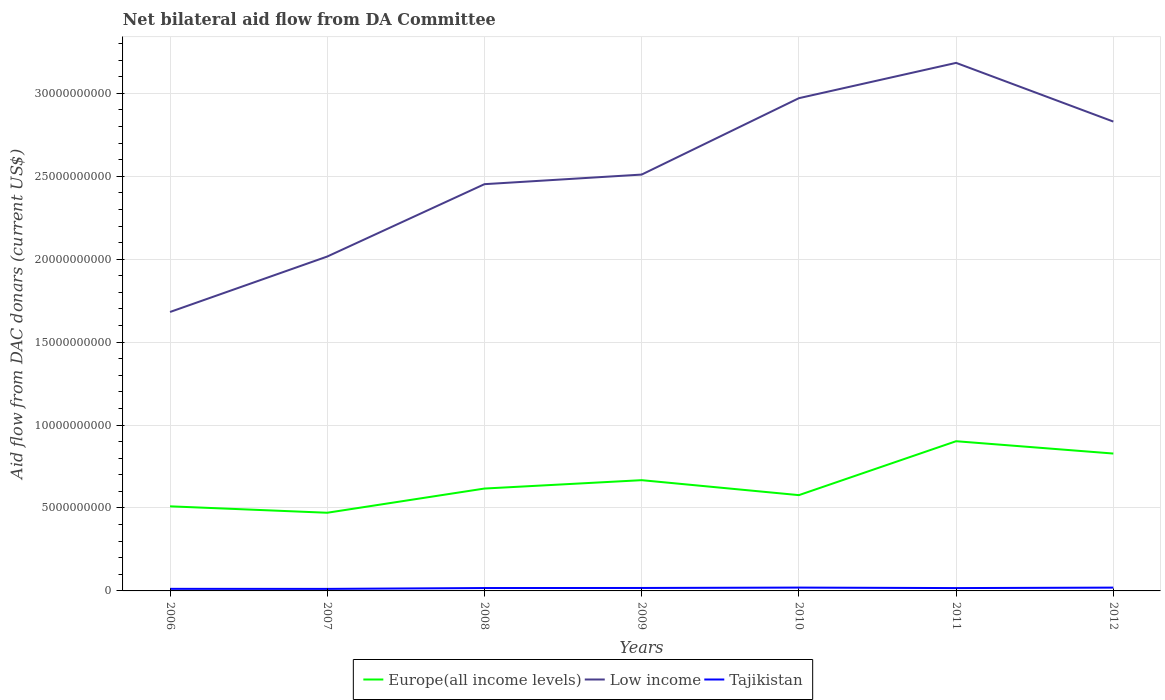Does the line corresponding to Tajikistan intersect with the line corresponding to Europe(all income levels)?
Your response must be concise. No. Is the number of lines equal to the number of legend labels?
Your response must be concise. Yes. Across all years, what is the maximum aid flow in in Europe(all income levels)?
Provide a short and direct response. 4.71e+09. What is the total aid flow in in Europe(all income levels) in the graph?
Ensure brevity in your answer.  3.97e+08. What is the difference between the highest and the second highest aid flow in in Europe(all income levels)?
Your answer should be very brief. 4.31e+09. What is the difference between the highest and the lowest aid flow in in Europe(all income levels)?
Provide a short and direct response. 3. How many years are there in the graph?
Your response must be concise. 7. Does the graph contain any zero values?
Provide a succinct answer. No. Does the graph contain grids?
Offer a terse response. Yes. How many legend labels are there?
Ensure brevity in your answer.  3. How are the legend labels stacked?
Offer a terse response. Horizontal. What is the title of the graph?
Give a very brief answer. Net bilateral aid flow from DA Committee. Does "Jamaica" appear as one of the legend labels in the graph?
Offer a terse response. No. What is the label or title of the Y-axis?
Your answer should be very brief. Aid flow from DAC donars (current US$). What is the Aid flow from DAC donars (current US$) in Europe(all income levels) in 2006?
Your answer should be compact. 5.10e+09. What is the Aid flow from DAC donars (current US$) of Low income in 2006?
Your answer should be compact. 1.68e+1. What is the Aid flow from DAC donars (current US$) of Tajikistan in 2006?
Offer a terse response. 1.25e+08. What is the Aid flow from DAC donars (current US$) in Europe(all income levels) in 2007?
Your response must be concise. 4.71e+09. What is the Aid flow from DAC donars (current US$) in Low income in 2007?
Provide a short and direct response. 2.02e+1. What is the Aid flow from DAC donars (current US$) of Tajikistan in 2007?
Provide a succinct answer. 1.22e+08. What is the Aid flow from DAC donars (current US$) of Europe(all income levels) in 2008?
Provide a succinct answer. 6.17e+09. What is the Aid flow from DAC donars (current US$) in Low income in 2008?
Your answer should be very brief. 2.45e+1. What is the Aid flow from DAC donars (current US$) in Tajikistan in 2008?
Offer a terse response. 1.75e+08. What is the Aid flow from DAC donars (current US$) of Europe(all income levels) in 2009?
Your answer should be very brief. 6.68e+09. What is the Aid flow from DAC donars (current US$) of Low income in 2009?
Ensure brevity in your answer.  2.51e+1. What is the Aid flow from DAC donars (current US$) in Tajikistan in 2009?
Your answer should be compact. 1.78e+08. What is the Aid flow from DAC donars (current US$) in Europe(all income levels) in 2010?
Make the answer very short. 5.78e+09. What is the Aid flow from DAC donars (current US$) of Low income in 2010?
Make the answer very short. 2.97e+1. What is the Aid flow from DAC donars (current US$) in Tajikistan in 2010?
Ensure brevity in your answer.  2.01e+08. What is the Aid flow from DAC donars (current US$) of Europe(all income levels) in 2011?
Your response must be concise. 9.03e+09. What is the Aid flow from DAC donars (current US$) in Low income in 2011?
Ensure brevity in your answer.  3.18e+1. What is the Aid flow from DAC donars (current US$) in Tajikistan in 2011?
Provide a short and direct response. 1.72e+08. What is the Aid flow from DAC donars (current US$) in Europe(all income levels) in 2012?
Your response must be concise. 8.28e+09. What is the Aid flow from DAC donars (current US$) of Low income in 2012?
Make the answer very short. 2.83e+1. What is the Aid flow from DAC donars (current US$) of Tajikistan in 2012?
Give a very brief answer. 1.99e+08. Across all years, what is the maximum Aid flow from DAC donars (current US$) of Europe(all income levels)?
Provide a short and direct response. 9.03e+09. Across all years, what is the maximum Aid flow from DAC donars (current US$) in Low income?
Your response must be concise. 3.18e+1. Across all years, what is the maximum Aid flow from DAC donars (current US$) of Tajikistan?
Provide a succinct answer. 2.01e+08. Across all years, what is the minimum Aid flow from DAC donars (current US$) in Europe(all income levels)?
Your response must be concise. 4.71e+09. Across all years, what is the minimum Aid flow from DAC donars (current US$) in Low income?
Offer a terse response. 1.68e+1. Across all years, what is the minimum Aid flow from DAC donars (current US$) in Tajikistan?
Provide a short and direct response. 1.22e+08. What is the total Aid flow from DAC donars (current US$) of Europe(all income levels) in the graph?
Offer a very short reply. 4.57e+1. What is the total Aid flow from DAC donars (current US$) of Low income in the graph?
Offer a terse response. 1.76e+11. What is the total Aid flow from DAC donars (current US$) in Tajikistan in the graph?
Your response must be concise. 1.17e+09. What is the difference between the Aid flow from DAC donars (current US$) in Europe(all income levels) in 2006 and that in 2007?
Your answer should be very brief. 3.87e+08. What is the difference between the Aid flow from DAC donars (current US$) in Low income in 2006 and that in 2007?
Your response must be concise. -3.34e+09. What is the difference between the Aid flow from DAC donars (current US$) of Tajikistan in 2006 and that in 2007?
Offer a terse response. 3.28e+06. What is the difference between the Aid flow from DAC donars (current US$) in Europe(all income levels) in 2006 and that in 2008?
Your answer should be very brief. -1.07e+09. What is the difference between the Aid flow from DAC donars (current US$) in Low income in 2006 and that in 2008?
Provide a succinct answer. -7.71e+09. What is the difference between the Aid flow from DAC donars (current US$) of Tajikistan in 2006 and that in 2008?
Provide a succinct answer. -4.92e+07. What is the difference between the Aid flow from DAC donars (current US$) in Europe(all income levels) in 2006 and that in 2009?
Your response must be concise. -1.58e+09. What is the difference between the Aid flow from DAC donars (current US$) of Low income in 2006 and that in 2009?
Ensure brevity in your answer.  -8.28e+09. What is the difference between the Aid flow from DAC donars (current US$) in Tajikistan in 2006 and that in 2009?
Offer a terse response. -5.29e+07. What is the difference between the Aid flow from DAC donars (current US$) in Europe(all income levels) in 2006 and that in 2010?
Offer a very short reply. -6.75e+08. What is the difference between the Aid flow from DAC donars (current US$) of Low income in 2006 and that in 2010?
Make the answer very short. -1.29e+1. What is the difference between the Aid flow from DAC donars (current US$) in Tajikistan in 2006 and that in 2010?
Give a very brief answer. -7.58e+07. What is the difference between the Aid flow from DAC donars (current US$) of Europe(all income levels) in 2006 and that in 2011?
Give a very brief answer. -3.93e+09. What is the difference between the Aid flow from DAC donars (current US$) of Low income in 2006 and that in 2011?
Provide a short and direct response. -1.50e+1. What is the difference between the Aid flow from DAC donars (current US$) of Tajikistan in 2006 and that in 2011?
Offer a very short reply. -4.61e+07. What is the difference between the Aid flow from DAC donars (current US$) of Europe(all income levels) in 2006 and that in 2012?
Offer a very short reply. -3.18e+09. What is the difference between the Aid flow from DAC donars (current US$) of Low income in 2006 and that in 2012?
Give a very brief answer. -1.15e+1. What is the difference between the Aid flow from DAC donars (current US$) in Tajikistan in 2006 and that in 2012?
Give a very brief answer. -7.38e+07. What is the difference between the Aid flow from DAC donars (current US$) of Europe(all income levels) in 2007 and that in 2008?
Your answer should be compact. -1.46e+09. What is the difference between the Aid flow from DAC donars (current US$) of Low income in 2007 and that in 2008?
Your response must be concise. -4.36e+09. What is the difference between the Aid flow from DAC donars (current US$) of Tajikistan in 2007 and that in 2008?
Provide a succinct answer. -5.25e+07. What is the difference between the Aid flow from DAC donars (current US$) in Europe(all income levels) in 2007 and that in 2009?
Keep it short and to the point. -1.96e+09. What is the difference between the Aid flow from DAC donars (current US$) of Low income in 2007 and that in 2009?
Ensure brevity in your answer.  -4.94e+09. What is the difference between the Aid flow from DAC donars (current US$) in Tajikistan in 2007 and that in 2009?
Your answer should be very brief. -5.62e+07. What is the difference between the Aid flow from DAC donars (current US$) of Europe(all income levels) in 2007 and that in 2010?
Keep it short and to the point. -1.06e+09. What is the difference between the Aid flow from DAC donars (current US$) in Low income in 2007 and that in 2010?
Provide a short and direct response. -9.55e+09. What is the difference between the Aid flow from DAC donars (current US$) in Tajikistan in 2007 and that in 2010?
Your response must be concise. -7.91e+07. What is the difference between the Aid flow from DAC donars (current US$) in Europe(all income levels) in 2007 and that in 2011?
Your response must be concise. -4.31e+09. What is the difference between the Aid flow from DAC donars (current US$) of Low income in 2007 and that in 2011?
Ensure brevity in your answer.  -1.17e+1. What is the difference between the Aid flow from DAC donars (current US$) in Tajikistan in 2007 and that in 2011?
Your response must be concise. -4.94e+07. What is the difference between the Aid flow from DAC donars (current US$) in Europe(all income levels) in 2007 and that in 2012?
Provide a short and direct response. -3.57e+09. What is the difference between the Aid flow from DAC donars (current US$) in Low income in 2007 and that in 2012?
Make the answer very short. -8.14e+09. What is the difference between the Aid flow from DAC donars (current US$) in Tajikistan in 2007 and that in 2012?
Give a very brief answer. -7.70e+07. What is the difference between the Aid flow from DAC donars (current US$) in Europe(all income levels) in 2008 and that in 2009?
Ensure brevity in your answer.  -5.05e+08. What is the difference between the Aid flow from DAC donars (current US$) of Low income in 2008 and that in 2009?
Offer a terse response. -5.78e+08. What is the difference between the Aid flow from DAC donars (current US$) in Tajikistan in 2008 and that in 2009?
Offer a terse response. -3.68e+06. What is the difference between the Aid flow from DAC donars (current US$) of Europe(all income levels) in 2008 and that in 2010?
Make the answer very short. 3.97e+08. What is the difference between the Aid flow from DAC donars (current US$) of Low income in 2008 and that in 2010?
Offer a very short reply. -5.18e+09. What is the difference between the Aid flow from DAC donars (current US$) of Tajikistan in 2008 and that in 2010?
Provide a succinct answer. -2.66e+07. What is the difference between the Aid flow from DAC donars (current US$) in Europe(all income levels) in 2008 and that in 2011?
Keep it short and to the point. -2.85e+09. What is the difference between the Aid flow from DAC donars (current US$) in Low income in 2008 and that in 2011?
Ensure brevity in your answer.  -7.31e+09. What is the difference between the Aid flow from DAC donars (current US$) of Tajikistan in 2008 and that in 2011?
Ensure brevity in your answer.  3.15e+06. What is the difference between the Aid flow from DAC donars (current US$) in Europe(all income levels) in 2008 and that in 2012?
Give a very brief answer. -2.11e+09. What is the difference between the Aid flow from DAC donars (current US$) in Low income in 2008 and that in 2012?
Provide a succinct answer. -3.77e+09. What is the difference between the Aid flow from DAC donars (current US$) in Tajikistan in 2008 and that in 2012?
Provide a short and direct response. -2.45e+07. What is the difference between the Aid flow from DAC donars (current US$) of Europe(all income levels) in 2009 and that in 2010?
Offer a terse response. 9.02e+08. What is the difference between the Aid flow from DAC donars (current US$) in Low income in 2009 and that in 2010?
Offer a terse response. -4.61e+09. What is the difference between the Aid flow from DAC donars (current US$) of Tajikistan in 2009 and that in 2010?
Give a very brief answer. -2.29e+07. What is the difference between the Aid flow from DAC donars (current US$) of Europe(all income levels) in 2009 and that in 2011?
Offer a very short reply. -2.35e+09. What is the difference between the Aid flow from DAC donars (current US$) of Low income in 2009 and that in 2011?
Ensure brevity in your answer.  -6.73e+09. What is the difference between the Aid flow from DAC donars (current US$) of Tajikistan in 2009 and that in 2011?
Your answer should be compact. 6.83e+06. What is the difference between the Aid flow from DAC donars (current US$) in Europe(all income levels) in 2009 and that in 2012?
Provide a succinct answer. -1.61e+09. What is the difference between the Aid flow from DAC donars (current US$) in Low income in 2009 and that in 2012?
Your answer should be compact. -3.20e+09. What is the difference between the Aid flow from DAC donars (current US$) of Tajikistan in 2009 and that in 2012?
Offer a terse response. -2.08e+07. What is the difference between the Aid flow from DAC donars (current US$) in Europe(all income levels) in 2010 and that in 2011?
Your response must be concise. -3.25e+09. What is the difference between the Aid flow from DAC donars (current US$) of Low income in 2010 and that in 2011?
Your response must be concise. -2.13e+09. What is the difference between the Aid flow from DAC donars (current US$) in Tajikistan in 2010 and that in 2011?
Offer a very short reply. 2.97e+07. What is the difference between the Aid flow from DAC donars (current US$) of Europe(all income levels) in 2010 and that in 2012?
Offer a very short reply. -2.51e+09. What is the difference between the Aid flow from DAC donars (current US$) of Low income in 2010 and that in 2012?
Offer a terse response. 1.41e+09. What is the difference between the Aid flow from DAC donars (current US$) in Tajikistan in 2010 and that in 2012?
Make the answer very short. 2.05e+06. What is the difference between the Aid flow from DAC donars (current US$) of Europe(all income levels) in 2011 and that in 2012?
Your answer should be very brief. 7.44e+08. What is the difference between the Aid flow from DAC donars (current US$) of Low income in 2011 and that in 2012?
Provide a succinct answer. 3.54e+09. What is the difference between the Aid flow from DAC donars (current US$) of Tajikistan in 2011 and that in 2012?
Keep it short and to the point. -2.77e+07. What is the difference between the Aid flow from DAC donars (current US$) in Europe(all income levels) in 2006 and the Aid flow from DAC donars (current US$) in Low income in 2007?
Your answer should be very brief. -1.51e+1. What is the difference between the Aid flow from DAC donars (current US$) in Europe(all income levels) in 2006 and the Aid flow from DAC donars (current US$) in Tajikistan in 2007?
Your response must be concise. 4.98e+09. What is the difference between the Aid flow from DAC donars (current US$) in Low income in 2006 and the Aid flow from DAC donars (current US$) in Tajikistan in 2007?
Your response must be concise. 1.67e+1. What is the difference between the Aid flow from DAC donars (current US$) in Europe(all income levels) in 2006 and the Aid flow from DAC donars (current US$) in Low income in 2008?
Your answer should be very brief. -1.94e+1. What is the difference between the Aid flow from DAC donars (current US$) in Europe(all income levels) in 2006 and the Aid flow from DAC donars (current US$) in Tajikistan in 2008?
Give a very brief answer. 4.93e+09. What is the difference between the Aid flow from DAC donars (current US$) of Low income in 2006 and the Aid flow from DAC donars (current US$) of Tajikistan in 2008?
Provide a short and direct response. 1.66e+1. What is the difference between the Aid flow from DAC donars (current US$) of Europe(all income levels) in 2006 and the Aid flow from DAC donars (current US$) of Low income in 2009?
Offer a terse response. -2.00e+1. What is the difference between the Aid flow from DAC donars (current US$) of Europe(all income levels) in 2006 and the Aid flow from DAC donars (current US$) of Tajikistan in 2009?
Your response must be concise. 4.92e+09. What is the difference between the Aid flow from DAC donars (current US$) of Low income in 2006 and the Aid flow from DAC donars (current US$) of Tajikistan in 2009?
Ensure brevity in your answer.  1.66e+1. What is the difference between the Aid flow from DAC donars (current US$) of Europe(all income levels) in 2006 and the Aid flow from DAC donars (current US$) of Low income in 2010?
Provide a short and direct response. -2.46e+1. What is the difference between the Aid flow from DAC donars (current US$) of Europe(all income levels) in 2006 and the Aid flow from DAC donars (current US$) of Tajikistan in 2010?
Your response must be concise. 4.90e+09. What is the difference between the Aid flow from DAC donars (current US$) of Low income in 2006 and the Aid flow from DAC donars (current US$) of Tajikistan in 2010?
Offer a very short reply. 1.66e+1. What is the difference between the Aid flow from DAC donars (current US$) in Europe(all income levels) in 2006 and the Aid flow from DAC donars (current US$) in Low income in 2011?
Your answer should be very brief. -2.67e+1. What is the difference between the Aid flow from DAC donars (current US$) in Europe(all income levels) in 2006 and the Aid flow from DAC donars (current US$) in Tajikistan in 2011?
Your response must be concise. 4.93e+09. What is the difference between the Aid flow from DAC donars (current US$) in Low income in 2006 and the Aid flow from DAC donars (current US$) in Tajikistan in 2011?
Offer a very short reply. 1.66e+1. What is the difference between the Aid flow from DAC donars (current US$) in Europe(all income levels) in 2006 and the Aid flow from DAC donars (current US$) in Low income in 2012?
Your answer should be compact. -2.32e+1. What is the difference between the Aid flow from DAC donars (current US$) in Europe(all income levels) in 2006 and the Aid flow from DAC donars (current US$) in Tajikistan in 2012?
Provide a succinct answer. 4.90e+09. What is the difference between the Aid flow from DAC donars (current US$) in Low income in 2006 and the Aid flow from DAC donars (current US$) in Tajikistan in 2012?
Your answer should be compact. 1.66e+1. What is the difference between the Aid flow from DAC donars (current US$) in Europe(all income levels) in 2007 and the Aid flow from DAC donars (current US$) in Low income in 2008?
Provide a succinct answer. -1.98e+1. What is the difference between the Aid flow from DAC donars (current US$) of Europe(all income levels) in 2007 and the Aid flow from DAC donars (current US$) of Tajikistan in 2008?
Offer a very short reply. 4.54e+09. What is the difference between the Aid flow from DAC donars (current US$) of Low income in 2007 and the Aid flow from DAC donars (current US$) of Tajikistan in 2008?
Your response must be concise. 2.00e+1. What is the difference between the Aid flow from DAC donars (current US$) in Europe(all income levels) in 2007 and the Aid flow from DAC donars (current US$) in Low income in 2009?
Ensure brevity in your answer.  -2.04e+1. What is the difference between the Aid flow from DAC donars (current US$) in Europe(all income levels) in 2007 and the Aid flow from DAC donars (current US$) in Tajikistan in 2009?
Your answer should be very brief. 4.54e+09. What is the difference between the Aid flow from DAC donars (current US$) of Low income in 2007 and the Aid flow from DAC donars (current US$) of Tajikistan in 2009?
Offer a terse response. 2.00e+1. What is the difference between the Aid flow from DAC donars (current US$) in Europe(all income levels) in 2007 and the Aid flow from DAC donars (current US$) in Low income in 2010?
Give a very brief answer. -2.50e+1. What is the difference between the Aid flow from DAC donars (current US$) in Europe(all income levels) in 2007 and the Aid flow from DAC donars (current US$) in Tajikistan in 2010?
Give a very brief answer. 4.51e+09. What is the difference between the Aid flow from DAC donars (current US$) of Low income in 2007 and the Aid flow from DAC donars (current US$) of Tajikistan in 2010?
Your answer should be compact. 2.00e+1. What is the difference between the Aid flow from DAC donars (current US$) of Europe(all income levels) in 2007 and the Aid flow from DAC donars (current US$) of Low income in 2011?
Keep it short and to the point. -2.71e+1. What is the difference between the Aid flow from DAC donars (current US$) of Europe(all income levels) in 2007 and the Aid flow from DAC donars (current US$) of Tajikistan in 2011?
Provide a short and direct response. 4.54e+09. What is the difference between the Aid flow from DAC donars (current US$) of Low income in 2007 and the Aid flow from DAC donars (current US$) of Tajikistan in 2011?
Your answer should be very brief. 2.00e+1. What is the difference between the Aid flow from DAC donars (current US$) of Europe(all income levels) in 2007 and the Aid flow from DAC donars (current US$) of Low income in 2012?
Offer a terse response. -2.36e+1. What is the difference between the Aid flow from DAC donars (current US$) in Europe(all income levels) in 2007 and the Aid flow from DAC donars (current US$) in Tajikistan in 2012?
Keep it short and to the point. 4.51e+09. What is the difference between the Aid flow from DAC donars (current US$) in Low income in 2007 and the Aid flow from DAC donars (current US$) in Tajikistan in 2012?
Make the answer very short. 2.00e+1. What is the difference between the Aid flow from DAC donars (current US$) of Europe(all income levels) in 2008 and the Aid flow from DAC donars (current US$) of Low income in 2009?
Offer a terse response. -1.89e+1. What is the difference between the Aid flow from DAC donars (current US$) in Europe(all income levels) in 2008 and the Aid flow from DAC donars (current US$) in Tajikistan in 2009?
Your answer should be compact. 5.99e+09. What is the difference between the Aid flow from DAC donars (current US$) of Low income in 2008 and the Aid flow from DAC donars (current US$) of Tajikistan in 2009?
Provide a short and direct response. 2.43e+1. What is the difference between the Aid flow from DAC donars (current US$) in Europe(all income levels) in 2008 and the Aid flow from DAC donars (current US$) in Low income in 2010?
Make the answer very short. -2.35e+1. What is the difference between the Aid flow from DAC donars (current US$) in Europe(all income levels) in 2008 and the Aid flow from DAC donars (current US$) in Tajikistan in 2010?
Provide a succinct answer. 5.97e+09. What is the difference between the Aid flow from DAC donars (current US$) of Low income in 2008 and the Aid flow from DAC donars (current US$) of Tajikistan in 2010?
Offer a terse response. 2.43e+1. What is the difference between the Aid flow from DAC donars (current US$) of Europe(all income levels) in 2008 and the Aid flow from DAC donars (current US$) of Low income in 2011?
Provide a succinct answer. -2.57e+1. What is the difference between the Aid flow from DAC donars (current US$) of Europe(all income levels) in 2008 and the Aid flow from DAC donars (current US$) of Tajikistan in 2011?
Give a very brief answer. 6.00e+09. What is the difference between the Aid flow from DAC donars (current US$) of Low income in 2008 and the Aid flow from DAC donars (current US$) of Tajikistan in 2011?
Make the answer very short. 2.44e+1. What is the difference between the Aid flow from DAC donars (current US$) in Europe(all income levels) in 2008 and the Aid flow from DAC donars (current US$) in Low income in 2012?
Make the answer very short. -2.21e+1. What is the difference between the Aid flow from DAC donars (current US$) of Europe(all income levels) in 2008 and the Aid flow from DAC donars (current US$) of Tajikistan in 2012?
Ensure brevity in your answer.  5.97e+09. What is the difference between the Aid flow from DAC donars (current US$) in Low income in 2008 and the Aid flow from DAC donars (current US$) in Tajikistan in 2012?
Give a very brief answer. 2.43e+1. What is the difference between the Aid flow from DAC donars (current US$) of Europe(all income levels) in 2009 and the Aid flow from DAC donars (current US$) of Low income in 2010?
Give a very brief answer. -2.30e+1. What is the difference between the Aid flow from DAC donars (current US$) in Europe(all income levels) in 2009 and the Aid flow from DAC donars (current US$) in Tajikistan in 2010?
Provide a succinct answer. 6.48e+09. What is the difference between the Aid flow from DAC donars (current US$) in Low income in 2009 and the Aid flow from DAC donars (current US$) in Tajikistan in 2010?
Keep it short and to the point. 2.49e+1. What is the difference between the Aid flow from DAC donars (current US$) of Europe(all income levels) in 2009 and the Aid flow from DAC donars (current US$) of Low income in 2011?
Offer a terse response. -2.52e+1. What is the difference between the Aid flow from DAC donars (current US$) in Europe(all income levels) in 2009 and the Aid flow from DAC donars (current US$) in Tajikistan in 2011?
Offer a terse response. 6.51e+09. What is the difference between the Aid flow from DAC donars (current US$) of Low income in 2009 and the Aid flow from DAC donars (current US$) of Tajikistan in 2011?
Provide a succinct answer. 2.49e+1. What is the difference between the Aid flow from DAC donars (current US$) in Europe(all income levels) in 2009 and the Aid flow from DAC donars (current US$) in Low income in 2012?
Make the answer very short. -2.16e+1. What is the difference between the Aid flow from DAC donars (current US$) of Europe(all income levels) in 2009 and the Aid flow from DAC donars (current US$) of Tajikistan in 2012?
Your response must be concise. 6.48e+09. What is the difference between the Aid flow from DAC donars (current US$) of Low income in 2009 and the Aid flow from DAC donars (current US$) of Tajikistan in 2012?
Offer a terse response. 2.49e+1. What is the difference between the Aid flow from DAC donars (current US$) of Europe(all income levels) in 2010 and the Aid flow from DAC donars (current US$) of Low income in 2011?
Your answer should be very brief. -2.61e+1. What is the difference between the Aid flow from DAC donars (current US$) in Europe(all income levels) in 2010 and the Aid flow from DAC donars (current US$) in Tajikistan in 2011?
Make the answer very short. 5.60e+09. What is the difference between the Aid flow from DAC donars (current US$) in Low income in 2010 and the Aid flow from DAC donars (current US$) in Tajikistan in 2011?
Your response must be concise. 2.95e+1. What is the difference between the Aid flow from DAC donars (current US$) in Europe(all income levels) in 2010 and the Aid flow from DAC donars (current US$) in Low income in 2012?
Keep it short and to the point. -2.25e+1. What is the difference between the Aid flow from DAC donars (current US$) of Europe(all income levels) in 2010 and the Aid flow from DAC donars (current US$) of Tajikistan in 2012?
Your response must be concise. 5.58e+09. What is the difference between the Aid flow from DAC donars (current US$) of Low income in 2010 and the Aid flow from DAC donars (current US$) of Tajikistan in 2012?
Your answer should be very brief. 2.95e+1. What is the difference between the Aid flow from DAC donars (current US$) in Europe(all income levels) in 2011 and the Aid flow from DAC donars (current US$) in Low income in 2012?
Your answer should be compact. -1.93e+1. What is the difference between the Aid flow from DAC donars (current US$) of Europe(all income levels) in 2011 and the Aid flow from DAC donars (current US$) of Tajikistan in 2012?
Keep it short and to the point. 8.83e+09. What is the difference between the Aid flow from DAC donars (current US$) of Low income in 2011 and the Aid flow from DAC donars (current US$) of Tajikistan in 2012?
Offer a terse response. 3.16e+1. What is the average Aid flow from DAC donars (current US$) in Europe(all income levels) per year?
Your answer should be compact. 6.54e+09. What is the average Aid flow from DAC donars (current US$) in Low income per year?
Ensure brevity in your answer.  2.52e+1. What is the average Aid flow from DAC donars (current US$) of Tajikistan per year?
Your answer should be compact. 1.68e+08. In the year 2006, what is the difference between the Aid flow from DAC donars (current US$) of Europe(all income levels) and Aid flow from DAC donars (current US$) of Low income?
Give a very brief answer. -1.17e+1. In the year 2006, what is the difference between the Aid flow from DAC donars (current US$) in Europe(all income levels) and Aid flow from DAC donars (current US$) in Tajikistan?
Give a very brief answer. 4.98e+09. In the year 2006, what is the difference between the Aid flow from DAC donars (current US$) of Low income and Aid flow from DAC donars (current US$) of Tajikistan?
Make the answer very short. 1.67e+1. In the year 2007, what is the difference between the Aid flow from DAC donars (current US$) in Europe(all income levels) and Aid flow from DAC donars (current US$) in Low income?
Your answer should be very brief. -1.54e+1. In the year 2007, what is the difference between the Aid flow from DAC donars (current US$) in Europe(all income levels) and Aid flow from DAC donars (current US$) in Tajikistan?
Offer a very short reply. 4.59e+09. In the year 2007, what is the difference between the Aid flow from DAC donars (current US$) of Low income and Aid flow from DAC donars (current US$) of Tajikistan?
Your answer should be very brief. 2.00e+1. In the year 2008, what is the difference between the Aid flow from DAC donars (current US$) in Europe(all income levels) and Aid flow from DAC donars (current US$) in Low income?
Give a very brief answer. -1.84e+1. In the year 2008, what is the difference between the Aid flow from DAC donars (current US$) of Europe(all income levels) and Aid flow from DAC donars (current US$) of Tajikistan?
Provide a short and direct response. 6.00e+09. In the year 2008, what is the difference between the Aid flow from DAC donars (current US$) of Low income and Aid flow from DAC donars (current US$) of Tajikistan?
Your answer should be very brief. 2.43e+1. In the year 2009, what is the difference between the Aid flow from DAC donars (current US$) in Europe(all income levels) and Aid flow from DAC donars (current US$) in Low income?
Provide a succinct answer. -1.84e+1. In the year 2009, what is the difference between the Aid flow from DAC donars (current US$) of Europe(all income levels) and Aid flow from DAC donars (current US$) of Tajikistan?
Give a very brief answer. 6.50e+09. In the year 2009, what is the difference between the Aid flow from DAC donars (current US$) in Low income and Aid flow from DAC donars (current US$) in Tajikistan?
Your answer should be compact. 2.49e+1. In the year 2010, what is the difference between the Aid flow from DAC donars (current US$) in Europe(all income levels) and Aid flow from DAC donars (current US$) in Low income?
Your response must be concise. -2.39e+1. In the year 2010, what is the difference between the Aid flow from DAC donars (current US$) in Europe(all income levels) and Aid flow from DAC donars (current US$) in Tajikistan?
Offer a terse response. 5.57e+09. In the year 2010, what is the difference between the Aid flow from DAC donars (current US$) of Low income and Aid flow from DAC donars (current US$) of Tajikistan?
Make the answer very short. 2.95e+1. In the year 2011, what is the difference between the Aid flow from DAC donars (current US$) of Europe(all income levels) and Aid flow from DAC donars (current US$) of Low income?
Your answer should be very brief. -2.28e+1. In the year 2011, what is the difference between the Aid flow from DAC donars (current US$) of Europe(all income levels) and Aid flow from DAC donars (current US$) of Tajikistan?
Provide a short and direct response. 8.85e+09. In the year 2011, what is the difference between the Aid flow from DAC donars (current US$) of Low income and Aid flow from DAC donars (current US$) of Tajikistan?
Your answer should be very brief. 3.17e+1. In the year 2012, what is the difference between the Aid flow from DAC donars (current US$) of Europe(all income levels) and Aid flow from DAC donars (current US$) of Low income?
Provide a succinct answer. -2.00e+1. In the year 2012, what is the difference between the Aid flow from DAC donars (current US$) of Europe(all income levels) and Aid flow from DAC donars (current US$) of Tajikistan?
Keep it short and to the point. 8.08e+09. In the year 2012, what is the difference between the Aid flow from DAC donars (current US$) of Low income and Aid flow from DAC donars (current US$) of Tajikistan?
Offer a very short reply. 2.81e+1. What is the ratio of the Aid flow from DAC donars (current US$) in Europe(all income levels) in 2006 to that in 2007?
Your response must be concise. 1.08. What is the ratio of the Aid flow from DAC donars (current US$) of Low income in 2006 to that in 2007?
Your response must be concise. 0.83. What is the ratio of the Aid flow from DAC donars (current US$) of Tajikistan in 2006 to that in 2007?
Offer a very short reply. 1.03. What is the ratio of the Aid flow from DAC donars (current US$) in Europe(all income levels) in 2006 to that in 2008?
Ensure brevity in your answer.  0.83. What is the ratio of the Aid flow from DAC donars (current US$) in Low income in 2006 to that in 2008?
Give a very brief answer. 0.69. What is the ratio of the Aid flow from DAC donars (current US$) in Tajikistan in 2006 to that in 2008?
Your response must be concise. 0.72. What is the ratio of the Aid flow from DAC donars (current US$) in Europe(all income levels) in 2006 to that in 2009?
Offer a very short reply. 0.76. What is the ratio of the Aid flow from DAC donars (current US$) in Low income in 2006 to that in 2009?
Provide a short and direct response. 0.67. What is the ratio of the Aid flow from DAC donars (current US$) of Tajikistan in 2006 to that in 2009?
Offer a very short reply. 0.7. What is the ratio of the Aid flow from DAC donars (current US$) of Europe(all income levels) in 2006 to that in 2010?
Your answer should be compact. 0.88. What is the ratio of the Aid flow from DAC donars (current US$) in Low income in 2006 to that in 2010?
Provide a succinct answer. 0.57. What is the ratio of the Aid flow from DAC donars (current US$) of Tajikistan in 2006 to that in 2010?
Your answer should be compact. 0.62. What is the ratio of the Aid flow from DAC donars (current US$) in Europe(all income levels) in 2006 to that in 2011?
Provide a short and direct response. 0.57. What is the ratio of the Aid flow from DAC donars (current US$) of Low income in 2006 to that in 2011?
Provide a short and direct response. 0.53. What is the ratio of the Aid flow from DAC donars (current US$) of Tajikistan in 2006 to that in 2011?
Keep it short and to the point. 0.73. What is the ratio of the Aid flow from DAC donars (current US$) of Europe(all income levels) in 2006 to that in 2012?
Offer a terse response. 0.62. What is the ratio of the Aid flow from DAC donars (current US$) of Low income in 2006 to that in 2012?
Give a very brief answer. 0.59. What is the ratio of the Aid flow from DAC donars (current US$) of Tajikistan in 2006 to that in 2012?
Offer a very short reply. 0.63. What is the ratio of the Aid flow from DAC donars (current US$) of Europe(all income levels) in 2007 to that in 2008?
Ensure brevity in your answer.  0.76. What is the ratio of the Aid flow from DAC donars (current US$) of Low income in 2007 to that in 2008?
Offer a terse response. 0.82. What is the ratio of the Aid flow from DAC donars (current US$) of Tajikistan in 2007 to that in 2008?
Make the answer very short. 0.7. What is the ratio of the Aid flow from DAC donars (current US$) in Europe(all income levels) in 2007 to that in 2009?
Your response must be concise. 0.71. What is the ratio of the Aid flow from DAC donars (current US$) in Low income in 2007 to that in 2009?
Your response must be concise. 0.8. What is the ratio of the Aid flow from DAC donars (current US$) in Tajikistan in 2007 to that in 2009?
Your answer should be compact. 0.69. What is the ratio of the Aid flow from DAC donars (current US$) of Europe(all income levels) in 2007 to that in 2010?
Give a very brief answer. 0.82. What is the ratio of the Aid flow from DAC donars (current US$) in Low income in 2007 to that in 2010?
Make the answer very short. 0.68. What is the ratio of the Aid flow from DAC donars (current US$) of Tajikistan in 2007 to that in 2010?
Offer a very short reply. 0.61. What is the ratio of the Aid flow from DAC donars (current US$) in Europe(all income levels) in 2007 to that in 2011?
Your answer should be compact. 0.52. What is the ratio of the Aid flow from DAC donars (current US$) in Low income in 2007 to that in 2011?
Offer a terse response. 0.63. What is the ratio of the Aid flow from DAC donars (current US$) in Tajikistan in 2007 to that in 2011?
Give a very brief answer. 0.71. What is the ratio of the Aid flow from DAC donars (current US$) of Europe(all income levels) in 2007 to that in 2012?
Give a very brief answer. 0.57. What is the ratio of the Aid flow from DAC donars (current US$) of Low income in 2007 to that in 2012?
Give a very brief answer. 0.71. What is the ratio of the Aid flow from DAC donars (current US$) of Tajikistan in 2007 to that in 2012?
Provide a succinct answer. 0.61. What is the ratio of the Aid flow from DAC donars (current US$) of Europe(all income levels) in 2008 to that in 2009?
Provide a succinct answer. 0.92. What is the ratio of the Aid flow from DAC donars (current US$) of Tajikistan in 2008 to that in 2009?
Make the answer very short. 0.98. What is the ratio of the Aid flow from DAC donars (current US$) in Europe(all income levels) in 2008 to that in 2010?
Provide a succinct answer. 1.07. What is the ratio of the Aid flow from DAC donars (current US$) in Low income in 2008 to that in 2010?
Offer a very short reply. 0.83. What is the ratio of the Aid flow from DAC donars (current US$) in Tajikistan in 2008 to that in 2010?
Your answer should be compact. 0.87. What is the ratio of the Aid flow from DAC donars (current US$) in Europe(all income levels) in 2008 to that in 2011?
Keep it short and to the point. 0.68. What is the ratio of the Aid flow from DAC donars (current US$) in Low income in 2008 to that in 2011?
Offer a very short reply. 0.77. What is the ratio of the Aid flow from DAC donars (current US$) in Tajikistan in 2008 to that in 2011?
Provide a succinct answer. 1.02. What is the ratio of the Aid flow from DAC donars (current US$) in Europe(all income levels) in 2008 to that in 2012?
Your response must be concise. 0.75. What is the ratio of the Aid flow from DAC donars (current US$) of Low income in 2008 to that in 2012?
Your response must be concise. 0.87. What is the ratio of the Aid flow from DAC donars (current US$) in Tajikistan in 2008 to that in 2012?
Provide a succinct answer. 0.88. What is the ratio of the Aid flow from DAC donars (current US$) in Europe(all income levels) in 2009 to that in 2010?
Keep it short and to the point. 1.16. What is the ratio of the Aid flow from DAC donars (current US$) in Low income in 2009 to that in 2010?
Offer a very short reply. 0.84. What is the ratio of the Aid flow from DAC donars (current US$) of Tajikistan in 2009 to that in 2010?
Your answer should be very brief. 0.89. What is the ratio of the Aid flow from DAC donars (current US$) of Europe(all income levels) in 2009 to that in 2011?
Keep it short and to the point. 0.74. What is the ratio of the Aid flow from DAC donars (current US$) in Low income in 2009 to that in 2011?
Ensure brevity in your answer.  0.79. What is the ratio of the Aid flow from DAC donars (current US$) of Tajikistan in 2009 to that in 2011?
Offer a terse response. 1.04. What is the ratio of the Aid flow from DAC donars (current US$) of Europe(all income levels) in 2009 to that in 2012?
Your answer should be compact. 0.81. What is the ratio of the Aid flow from DAC donars (current US$) in Low income in 2009 to that in 2012?
Provide a succinct answer. 0.89. What is the ratio of the Aid flow from DAC donars (current US$) in Tajikistan in 2009 to that in 2012?
Your response must be concise. 0.9. What is the ratio of the Aid flow from DAC donars (current US$) in Europe(all income levels) in 2010 to that in 2011?
Your answer should be very brief. 0.64. What is the ratio of the Aid flow from DAC donars (current US$) in Low income in 2010 to that in 2011?
Ensure brevity in your answer.  0.93. What is the ratio of the Aid flow from DAC donars (current US$) of Tajikistan in 2010 to that in 2011?
Your answer should be very brief. 1.17. What is the ratio of the Aid flow from DAC donars (current US$) of Europe(all income levels) in 2010 to that in 2012?
Ensure brevity in your answer.  0.7. What is the ratio of the Aid flow from DAC donars (current US$) in Low income in 2010 to that in 2012?
Your answer should be compact. 1.05. What is the ratio of the Aid flow from DAC donars (current US$) in Tajikistan in 2010 to that in 2012?
Offer a terse response. 1.01. What is the ratio of the Aid flow from DAC donars (current US$) in Europe(all income levels) in 2011 to that in 2012?
Provide a succinct answer. 1.09. What is the ratio of the Aid flow from DAC donars (current US$) in Low income in 2011 to that in 2012?
Provide a short and direct response. 1.13. What is the ratio of the Aid flow from DAC donars (current US$) of Tajikistan in 2011 to that in 2012?
Keep it short and to the point. 0.86. What is the difference between the highest and the second highest Aid flow from DAC donars (current US$) of Europe(all income levels)?
Offer a very short reply. 7.44e+08. What is the difference between the highest and the second highest Aid flow from DAC donars (current US$) in Low income?
Keep it short and to the point. 2.13e+09. What is the difference between the highest and the second highest Aid flow from DAC donars (current US$) of Tajikistan?
Offer a terse response. 2.05e+06. What is the difference between the highest and the lowest Aid flow from DAC donars (current US$) of Europe(all income levels)?
Your response must be concise. 4.31e+09. What is the difference between the highest and the lowest Aid flow from DAC donars (current US$) of Low income?
Make the answer very short. 1.50e+1. What is the difference between the highest and the lowest Aid flow from DAC donars (current US$) in Tajikistan?
Ensure brevity in your answer.  7.91e+07. 